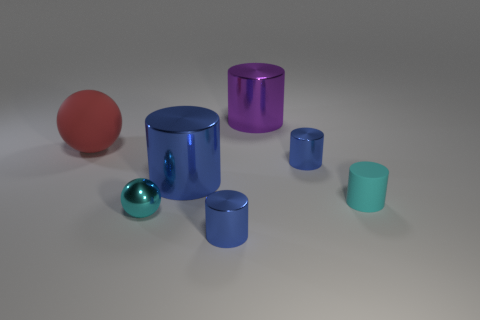Subtract all green spheres. How many blue cylinders are left? 3 Subtract all purple metallic cylinders. How many cylinders are left? 4 Subtract all cyan cylinders. How many cylinders are left? 4 Subtract all brown cylinders. Subtract all cyan spheres. How many cylinders are left? 5 Add 2 large red rubber objects. How many objects exist? 9 Subtract all spheres. How many objects are left? 5 Subtract 1 cyan spheres. How many objects are left? 6 Subtract all tiny metallic cylinders. Subtract all blue things. How many objects are left? 2 Add 6 big purple shiny cylinders. How many big purple shiny cylinders are left? 7 Add 6 tiny shiny cylinders. How many tiny shiny cylinders exist? 8 